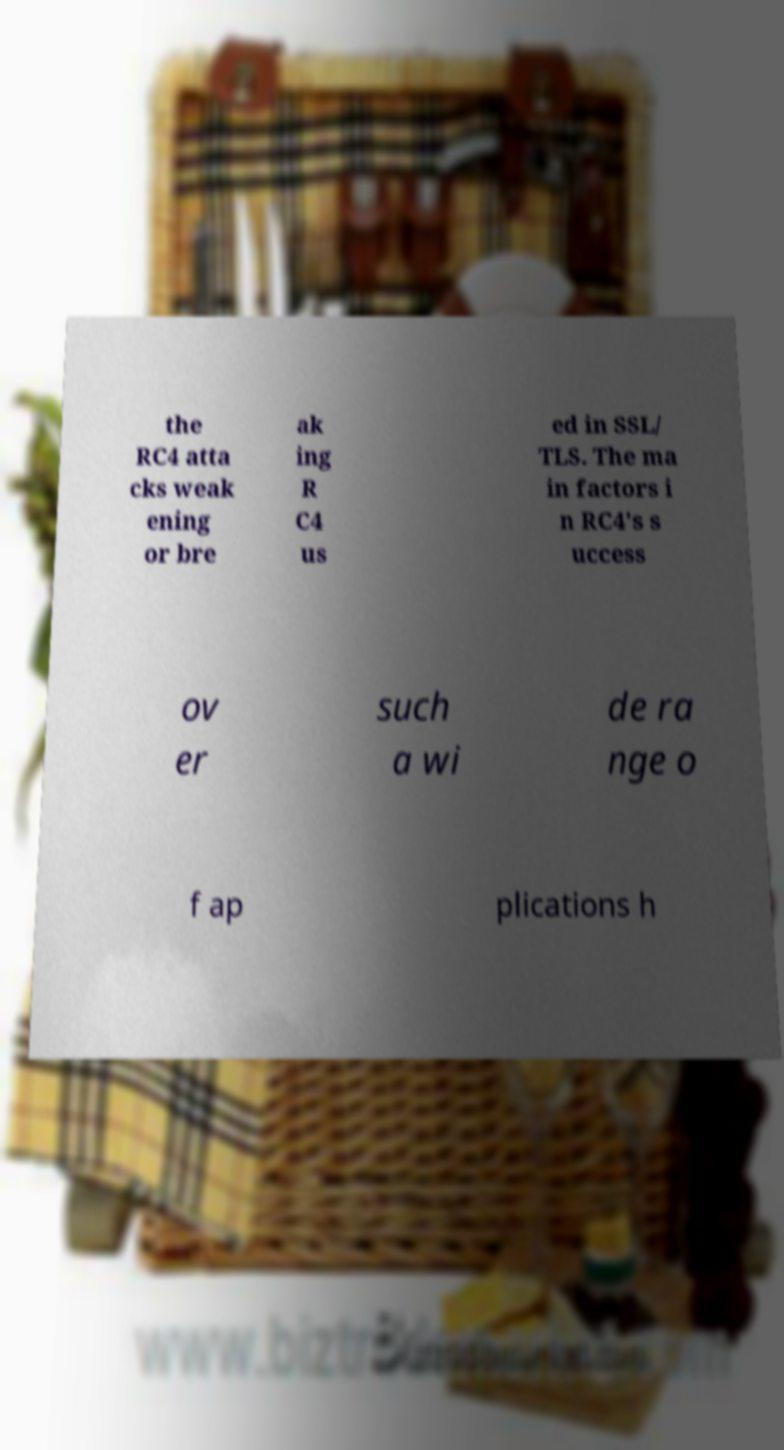Could you extract and type out the text from this image? the RC4 atta cks weak ening or bre ak ing R C4 us ed in SSL/ TLS. The ma in factors i n RC4's s uccess ov er such a wi de ra nge o f ap plications h 